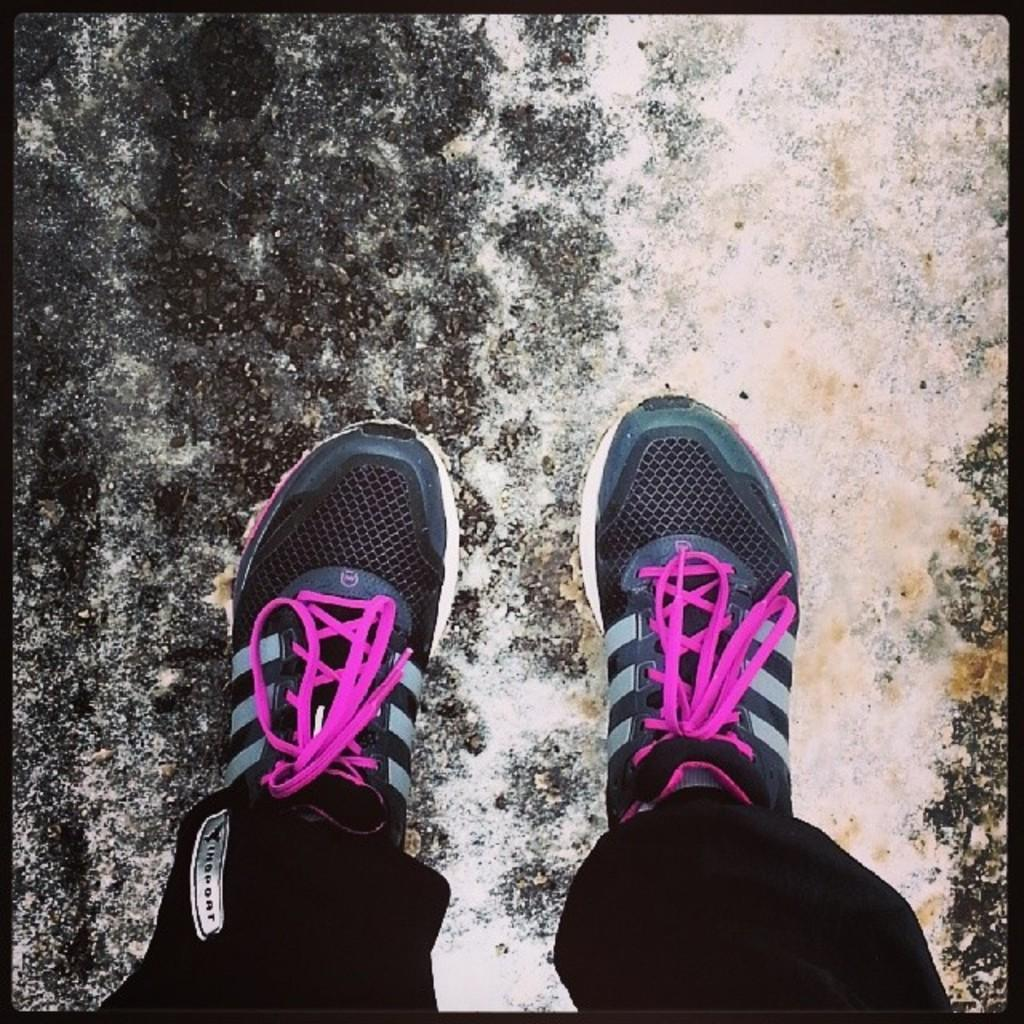What is the main subject of the image? There is a person standing in the image. Where is the person standing? The person is standing on the floor. How is the person positioned in the image? The person is in the middle of the image. How many chickens can be seen in the image? There are no chickens present in the image. What type of medical facility is depicted in the image? There is no hospital or medical facility depicted in the image. 